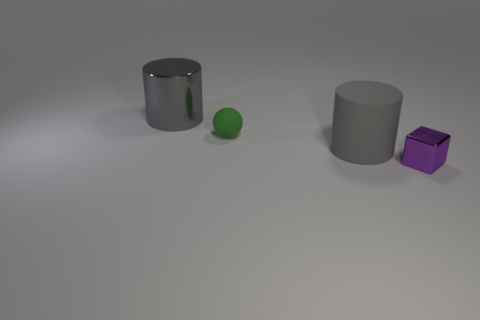There is another thing that is the same shape as the large shiny thing; what is its material?
Give a very brief answer. Rubber. There is a metallic thing in front of the small thing behind the metallic thing right of the big shiny cylinder; what size is it?
Your answer should be very brief. Small. Is the size of the gray metal cylinder the same as the purple thing?
Provide a succinct answer. No. What is the material of the small thing behind the small thing right of the big gray rubber object?
Provide a succinct answer. Rubber. Is the shape of the tiny thing behind the tiny metallic object the same as the big object that is left of the big matte object?
Offer a very short reply. No. Are there an equal number of large rubber things that are on the left side of the small rubber sphere and gray objects?
Provide a short and direct response. No. Are there any small shiny things that are behind the shiny thing to the left of the tiny shiny block?
Ensure brevity in your answer.  No. Is there any other thing that has the same color as the matte sphere?
Offer a very short reply. No. Is the material of the small thing behind the small block the same as the small block?
Provide a succinct answer. No. Are there the same number of large shiny cylinders that are in front of the metal cylinder and green spheres on the left side of the small ball?
Give a very brief answer. Yes. 